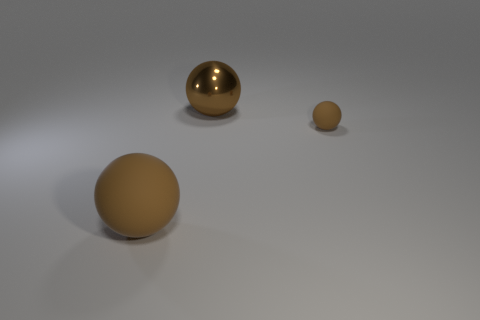Subtract all brown spheres. How many were subtracted if there are1brown spheres left? 2 Add 2 tiny brown things. How many objects exist? 5 Subtract 0 yellow balls. How many objects are left? 3 Subtract all big balls. Subtract all large shiny balls. How many objects are left? 0 Add 1 balls. How many balls are left? 4 Add 3 gray metallic spheres. How many gray metallic spheres exist? 3 